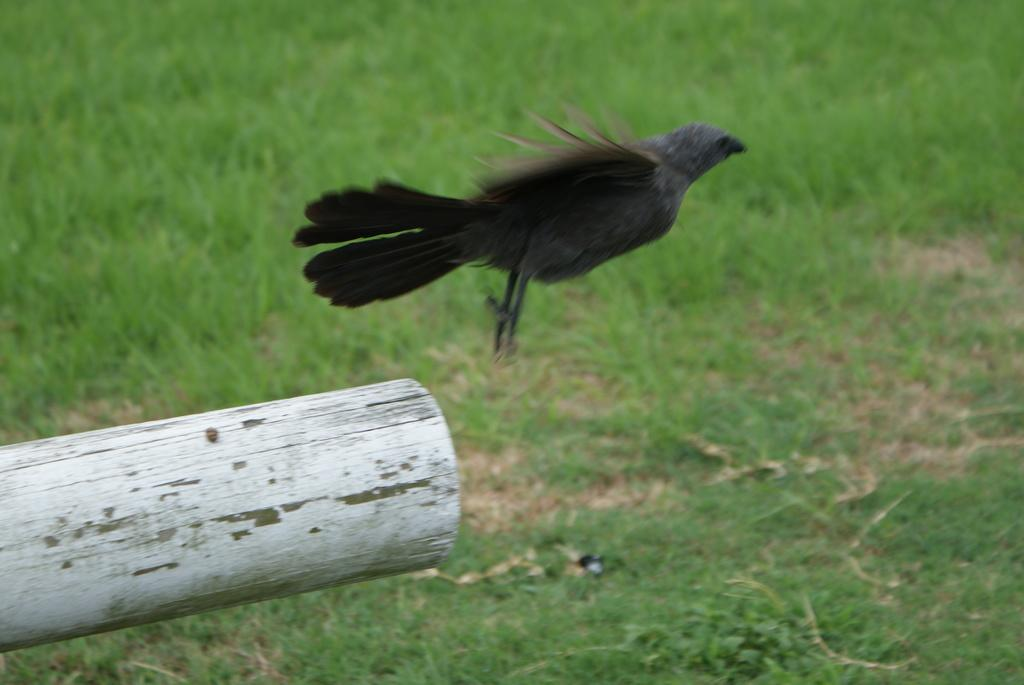What type of animal is in the image? There is a bird in the image. What colors can be seen on the bird? The bird is in black and grey color. What is the bird sitting on in the image? There is a branch to the left of the bird. What type of vegetation is visible in the background of the image? There is grass visible in the background of the image. What type of reaction does the bird have to the hydrant in the image? There is no hydrant present in the image, so the bird cannot have a reaction to it. 